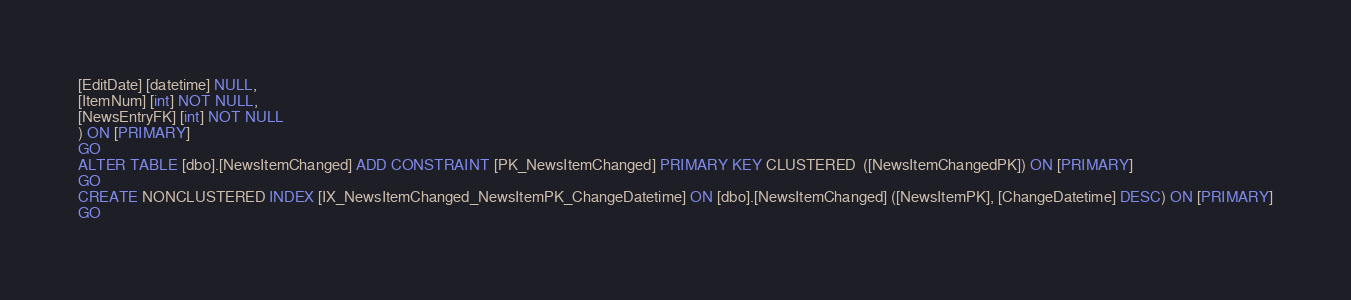Convert code to text. <code><loc_0><loc_0><loc_500><loc_500><_SQL_>[EditDate] [datetime] NULL,
[ItemNum] [int] NOT NULL,
[NewsEntryFK] [int] NOT NULL
) ON [PRIMARY]
GO
ALTER TABLE [dbo].[NewsItemChanged] ADD CONSTRAINT [PK_NewsItemChanged] PRIMARY KEY CLUSTERED  ([NewsItemChangedPK]) ON [PRIMARY]
GO
CREATE NONCLUSTERED INDEX [IX_NewsItemChanged_NewsItemPK_ChangeDatetime] ON [dbo].[NewsItemChanged] ([NewsItemPK], [ChangeDatetime] DESC) ON [PRIMARY]
GO
</code> 